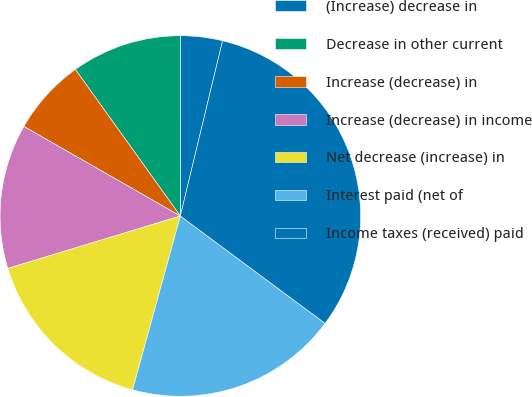Convert chart. <chart><loc_0><loc_0><loc_500><loc_500><pie_chart><fcel>(Increase) decrease in<fcel>Decrease in other current<fcel>Increase (decrease) in<fcel>Increase (decrease) in income<fcel>Net decrease (increase) in<fcel>Interest paid (net of<fcel>Income taxes (received) paid<nl><fcel>3.76%<fcel>9.9%<fcel>6.83%<fcel>12.97%<fcel>16.04%<fcel>19.11%<fcel>31.39%<nl></chart> 